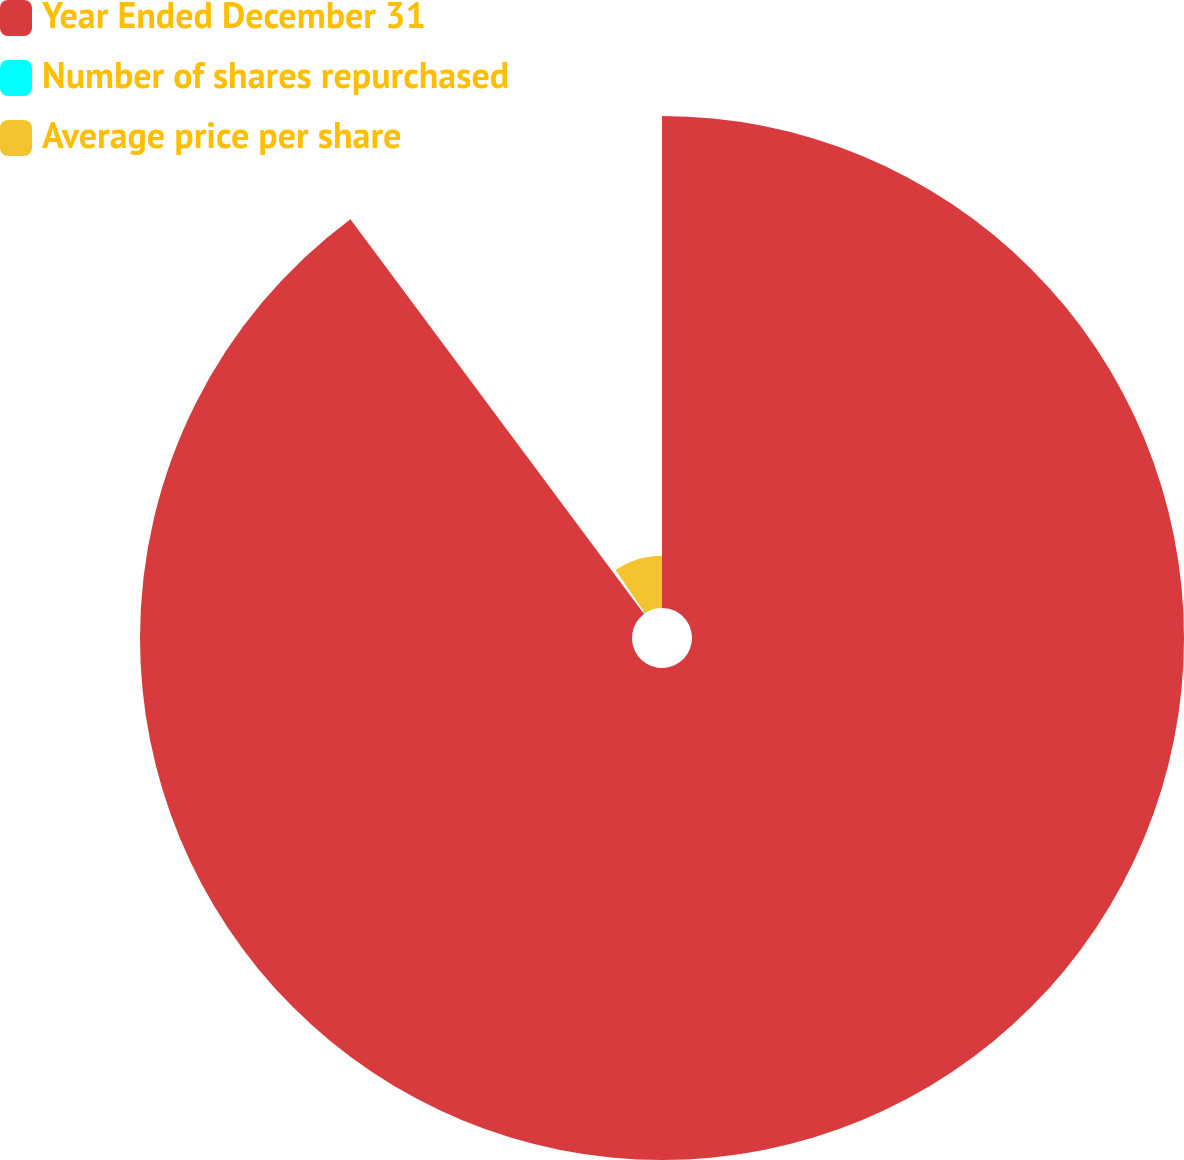Convert chart. <chart><loc_0><loc_0><loc_500><loc_500><pie_chart><fcel>Year Ended December 31<fcel>Number of shares repurchased<fcel>Average price per share<nl><fcel>89.82%<fcel>0.63%<fcel>9.55%<nl></chart> 